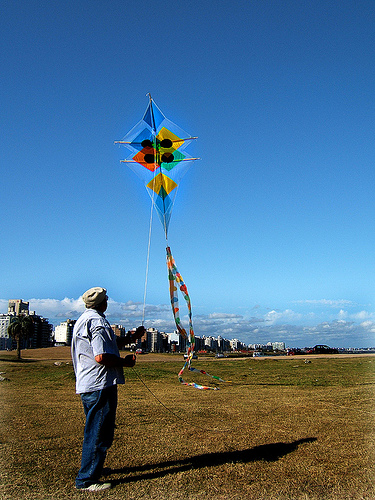How does flying a kite like this affect a person's well-being? Kite flying is a calming and relaxing activity that can help reduce stress and promote a feeling of well-being. It encourages individuals to be outdoors, enjoying the fresh air and sunshine, which can boost overall mood and provide a pleasant break from the routines of daily life. Furthermore, kite flying can also be a fun and engaging way to experience a simple and traditional form of entertainment. 